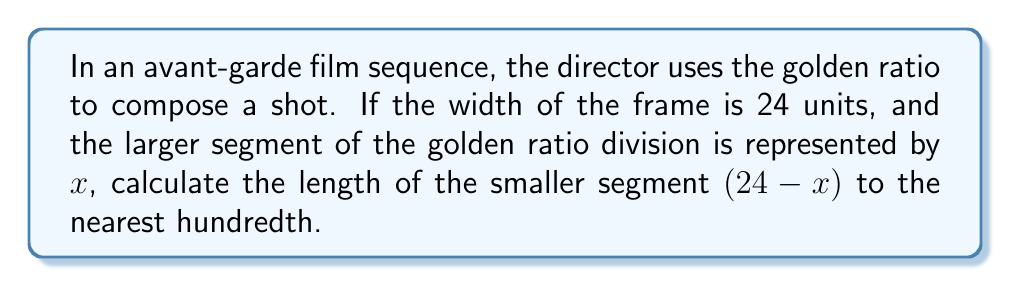Teach me how to tackle this problem. Let's approach this step-by-step:

1) The golden ratio is defined as the ratio of the larger segment to the smaller segment, which is equal to the ratio of the whole to the larger segment. Mathematically, this is expressed as:

   $$\frac{x}{24-x} = \frac{24}{x}$$

2) Cross-multiplying, we get:
   $$x^2 = 24(24-x)$$

3) Expanding the right side:
   $$x^2 = 576 - 24x$$

4) Rearranging terms:
   $$x^2 + 24x - 576 = 0$$

5) This is a quadratic equation. We can solve it using the quadratic formula:
   $$x = \frac{-b \pm \sqrt{b^2 - 4ac}}{2a}$$

   Where $a=1$, $b=24$, and $c=-576$

6) Substituting these values:
   $$x = \frac{-24 \pm \sqrt{24^2 - 4(1)(-576)}}{2(1)}$$

7) Simplifying:
   $$x = \frac{-24 \pm \sqrt{576 + 2304}}{2} = \frac{-24 \pm \sqrt{2880}}{2}$$

8) Continuing:
   $$x = \frac{-24 \pm 53.6656}{2}$$

9) This gives us two solutions:
   $$x = 14.8328 \text{ or } x = -38.8328$$

10) Since we're dealing with a physical length, we take the positive solution:
    $$x \approx 14.8328$$

11) The smaller segment is (24 - $x$):
    $$24 - 14.8328 = 9.1672$$

12) Rounding to the nearest hundredth:
    $$9.17$$
Answer: 9.17 